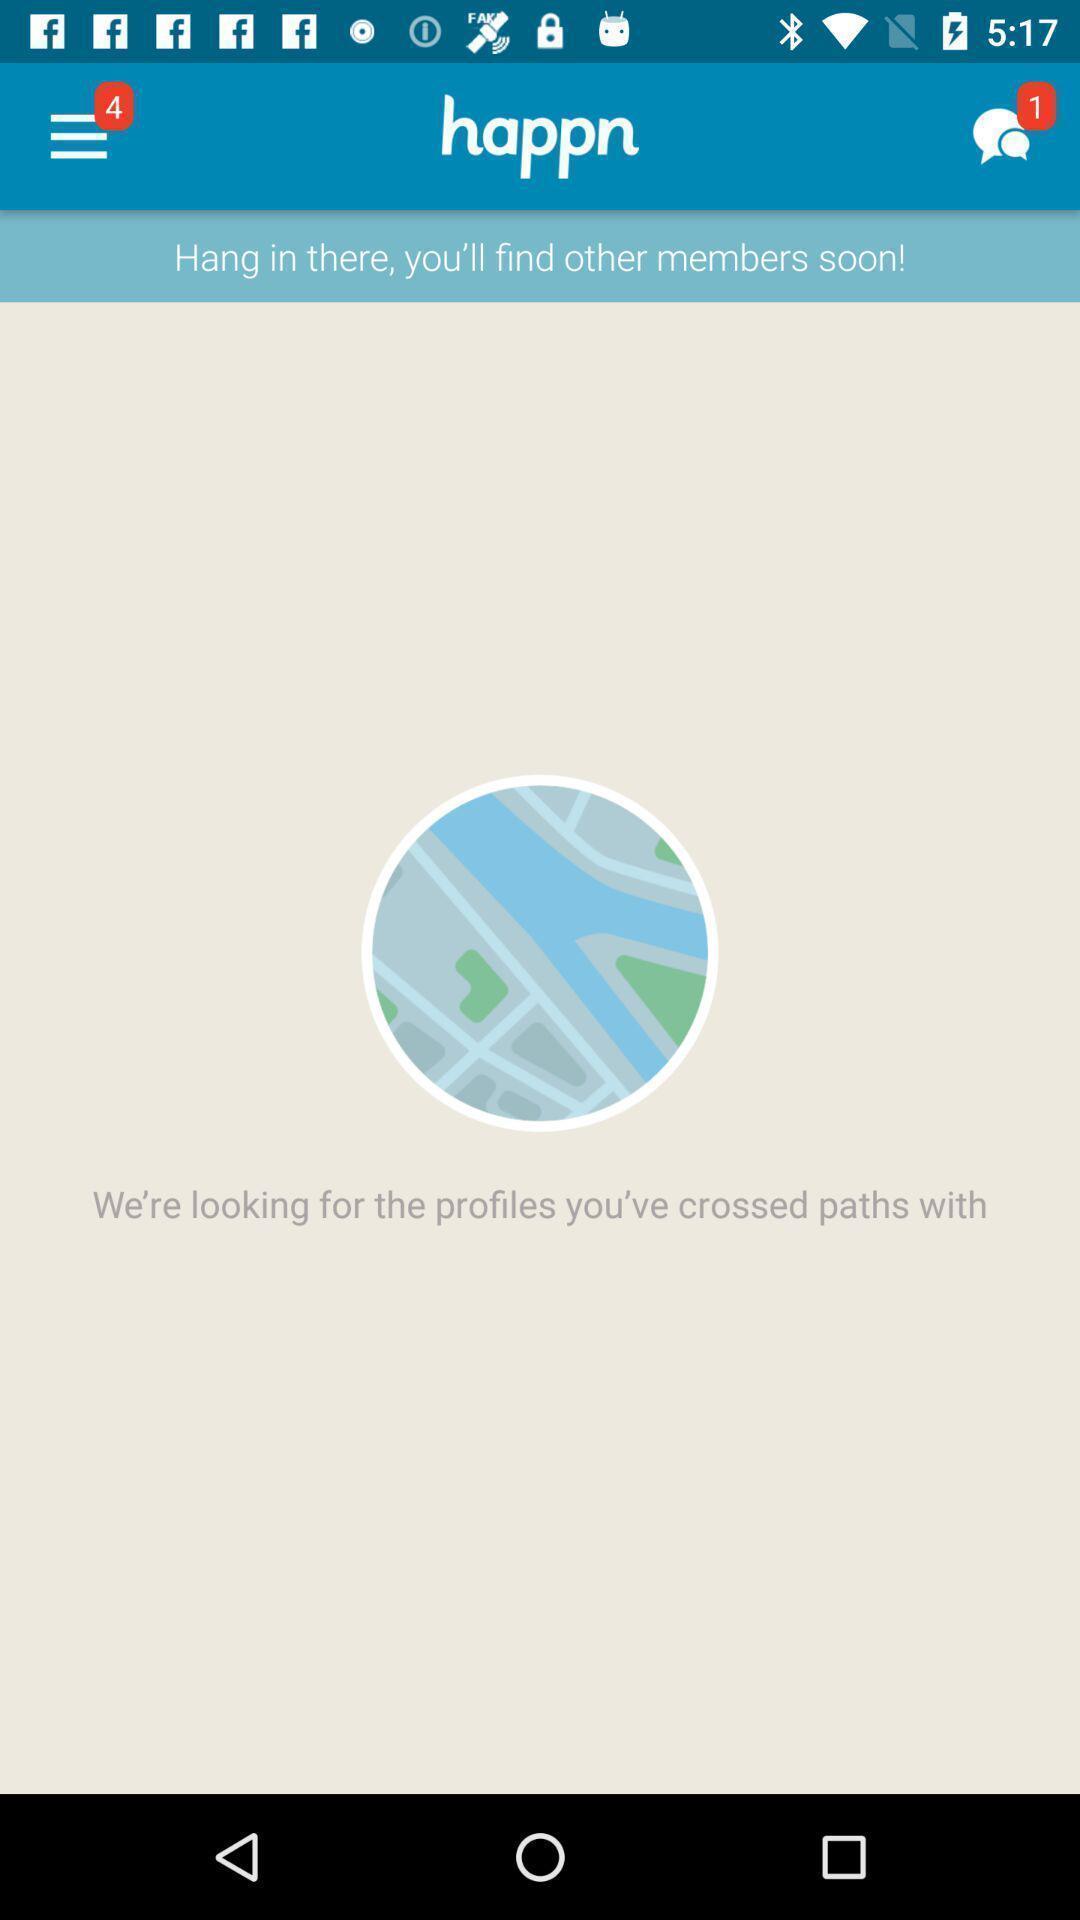What is the overall content of this screenshot? Screen displaying page of an social application. 